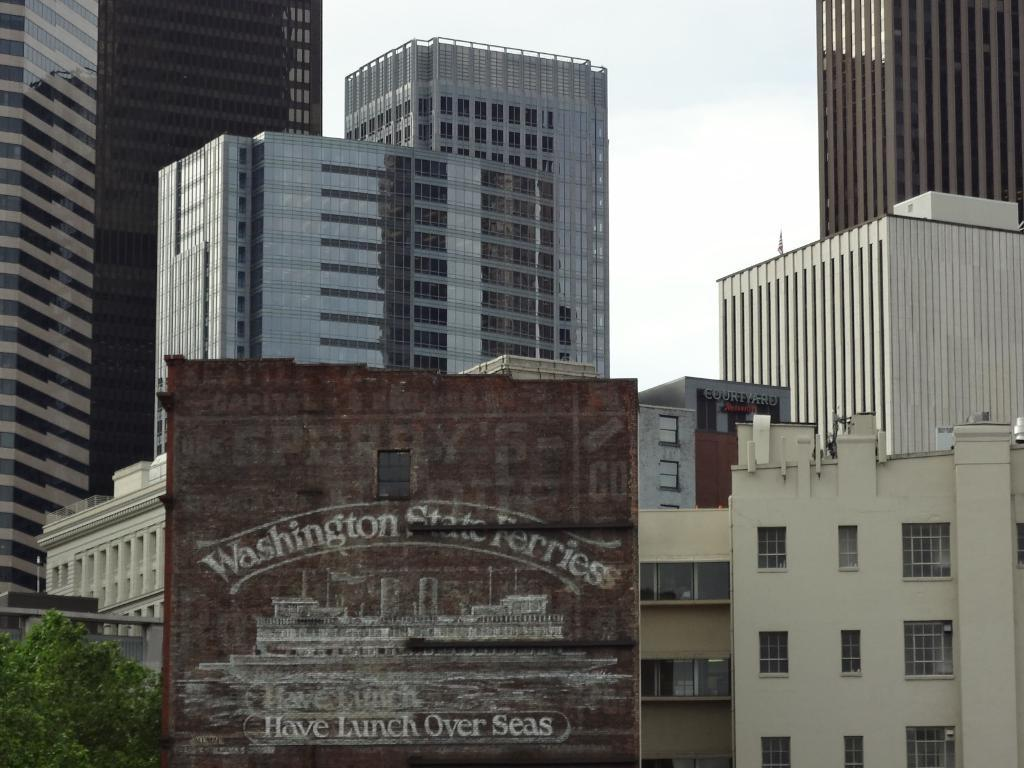What is the main object in the center of the image? There is a board in the center of the image. What is located next to the board? There is a tree beside the board. What can be seen in the distance behind the board and tree? There are buildings in the background of the image. What part of the natural environment is visible in the image? The sky is visible in the background of the image. What is the weight of the cough that can be heard in the image? There is no cough or sound present in the image, so it's not possible to determine the weight of a cough. 